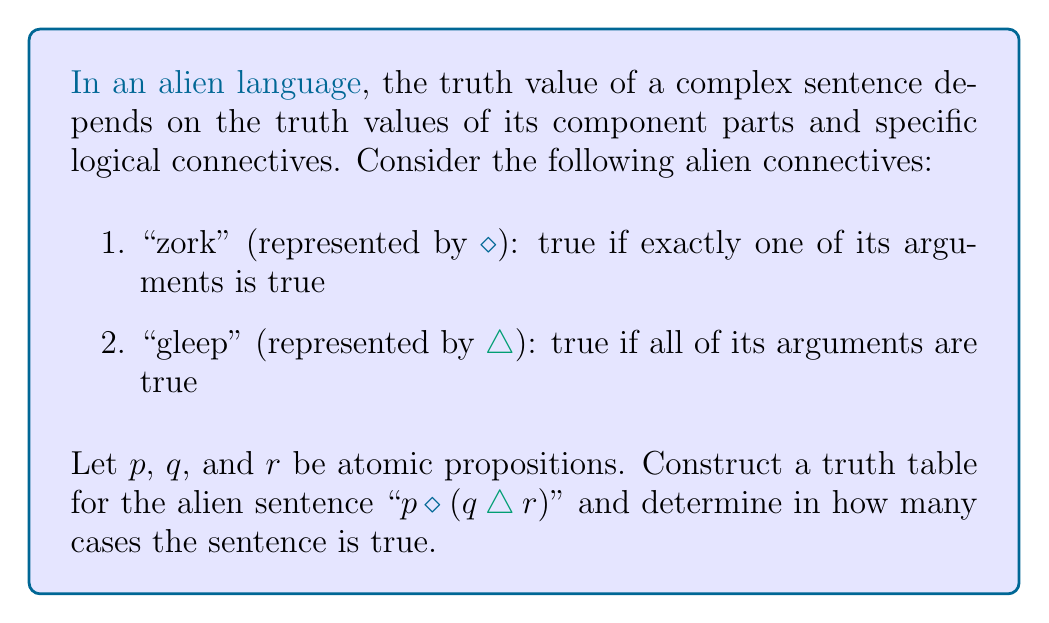Can you answer this question? To solve this problem, we need to use propositional calculus to model the truth conditions of the alien language's semantics. Let's break it down step-by-step:

1. First, we need to understand the logical connectives:
   - "zork" ($\diamond$) is equivalent to the exclusive OR (XOR) operation
   - "gleep" ($\triangle$) is equivalent to the AND operation

2. The sentence structure is: $p \diamond (q \triangle r)$

3. Let's construct the truth table:

   | $p$ | $q$ | $r$ | $q \triangle r$ | $p \diamond (q \triangle r)$ |
   |-----|-----|-----|-----------------|------------------------------|
   | T   | T   | T   | T               | F                            |
   | T   | T   | F   | F               | T                            |
   | T   | F   | T   | F               | T                            |
   | T   | F   | F   | F               | T                            |
   | F   | T   | T   | T               | T                            |
   | F   | T   | F   | F               | F                            |
   | F   | F   | T   | F               | F                            |
   | F   | F   | F   | F               | F                            |

4. Explanation of the truth table:
   - The first three columns represent all possible combinations of truth values for $p$, $q$, and $r$.
   - The fourth column ($q \triangle r$) is true only when both $q$ and $r$ are true.
   - The last column ($p \diamond (q \triangle r)$) is true when exactly one of $p$ and $(q \triangle r)$ is true.

5. Counting the number of true cases:
   In the last column, we can see that the sentence is true in 4 cases.
Answer: The alien sentence "p zork (q gleep r)" is true in 4 out of 8 possible cases. 